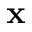Convert formula to latex. <formula><loc_0><loc_0><loc_500><loc_500>x</formula> 